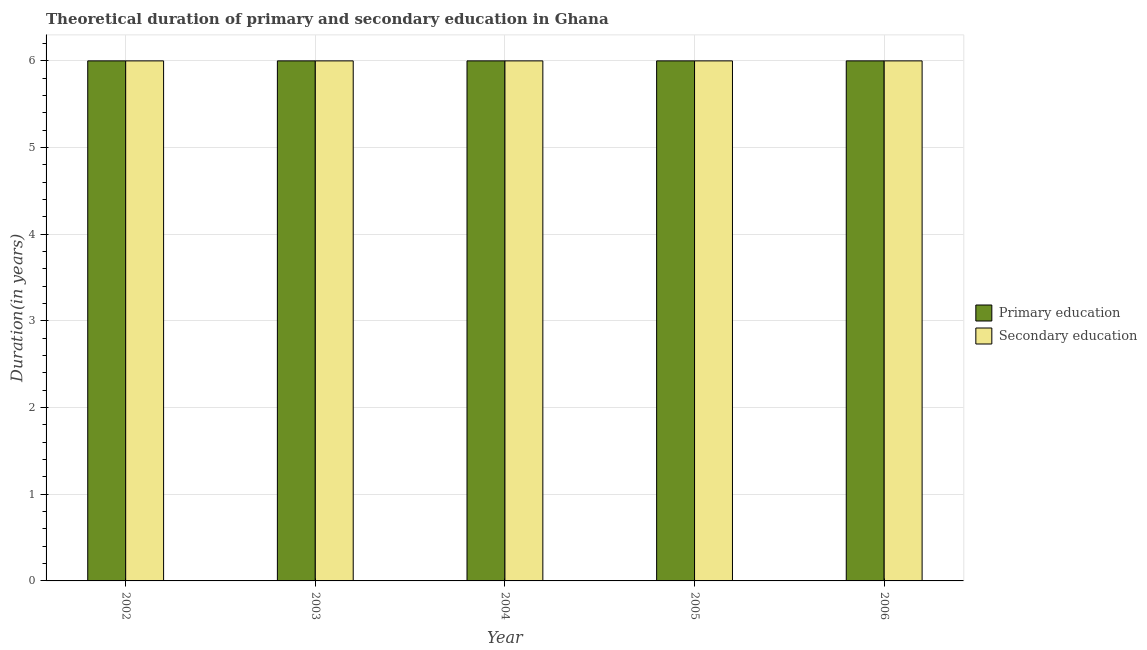How many different coloured bars are there?
Your answer should be compact. 2. Are the number of bars per tick equal to the number of legend labels?
Offer a very short reply. Yes. How many bars are there on the 1st tick from the left?
Ensure brevity in your answer.  2. What is the label of the 1st group of bars from the left?
Your answer should be very brief. 2002. Across all years, what is the maximum duration of primary education?
Make the answer very short. 6. Across all years, what is the minimum duration of secondary education?
Your answer should be compact. 6. What is the total duration of primary education in the graph?
Provide a short and direct response. 30. In the year 2005, what is the difference between the duration of primary education and duration of secondary education?
Keep it short and to the point. 0. In how many years, is the duration of primary education greater than 1.4 years?
Ensure brevity in your answer.  5. Is the duration of primary education in 2003 less than that in 2006?
Your answer should be very brief. No. What is the difference between the highest and the lowest duration of secondary education?
Your answer should be compact. 0. Is the sum of the duration of secondary education in 2003 and 2004 greater than the maximum duration of primary education across all years?
Keep it short and to the point. Yes. What does the 1st bar from the left in 2003 represents?
Offer a very short reply. Primary education. What does the 2nd bar from the right in 2005 represents?
Your answer should be compact. Primary education. How many bars are there?
Offer a terse response. 10. Are all the bars in the graph horizontal?
Provide a short and direct response. No. What is the difference between two consecutive major ticks on the Y-axis?
Keep it short and to the point. 1. Are the values on the major ticks of Y-axis written in scientific E-notation?
Provide a succinct answer. No. Does the graph contain any zero values?
Your answer should be compact. No. Does the graph contain grids?
Offer a very short reply. Yes. Where does the legend appear in the graph?
Make the answer very short. Center right. How many legend labels are there?
Keep it short and to the point. 2. What is the title of the graph?
Offer a very short reply. Theoretical duration of primary and secondary education in Ghana. Does "Ages 15-24" appear as one of the legend labels in the graph?
Offer a terse response. No. What is the label or title of the X-axis?
Make the answer very short. Year. What is the label or title of the Y-axis?
Your answer should be compact. Duration(in years). What is the Duration(in years) in Primary education in 2002?
Ensure brevity in your answer.  6. What is the Duration(in years) of Secondary education in 2002?
Your answer should be very brief. 6. What is the Duration(in years) of Secondary education in 2006?
Keep it short and to the point. 6. Across all years, what is the maximum Duration(in years) in Secondary education?
Your answer should be compact. 6. Across all years, what is the minimum Duration(in years) of Secondary education?
Your answer should be compact. 6. What is the total Duration(in years) of Secondary education in the graph?
Provide a succinct answer. 30. What is the difference between the Duration(in years) of Primary education in 2002 and that in 2003?
Your answer should be very brief. 0. What is the difference between the Duration(in years) of Primary education in 2002 and that in 2004?
Make the answer very short. 0. What is the difference between the Duration(in years) of Secondary education in 2002 and that in 2004?
Your answer should be compact. 0. What is the difference between the Duration(in years) in Secondary education in 2002 and that in 2005?
Offer a terse response. 0. What is the difference between the Duration(in years) of Primary education in 2002 and that in 2006?
Ensure brevity in your answer.  0. What is the difference between the Duration(in years) in Secondary education in 2002 and that in 2006?
Your response must be concise. 0. What is the difference between the Duration(in years) in Primary education in 2003 and that in 2005?
Offer a terse response. 0. What is the difference between the Duration(in years) in Secondary education in 2003 and that in 2006?
Offer a very short reply. 0. What is the difference between the Duration(in years) of Secondary education in 2004 and that in 2005?
Your answer should be very brief. 0. What is the difference between the Duration(in years) in Primary education in 2002 and the Duration(in years) in Secondary education in 2003?
Give a very brief answer. 0. What is the difference between the Duration(in years) in Primary education in 2003 and the Duration(in years) in Secondary education in 2006?
Offer a terse response. 0. What is the difference between the Duration(in years) of Primary education in 2004 and the Duration(in years) of Secondary education in 2005?
Provide a short and direct response. 0. What is the difference between the Duration(in years) in Primary education in 2004 and the Duration(in years) in Secondary education in 2006?
Give a very brief answer. 0. What is the average Duration(in years) in Secondary education per year?
Give a very brief answer. 6. In the year 2002, what is the difference between the Duration(in years) of Primary education and Duration(in years) of Secondary education?
Give a very brief answer. 0. In the year 2004, what is the difference between the Duration(in years) in Primary education and Duration(in years) in Secondary education?
Provide a succinct answer. 0. In the year 2005, what is the difference between the Duration(in years) in Primary education and Duration(in years) in Secondary education?
Make the answer very short. 0. What is the ratio of the Duration(in years) of Primary education in 2002 to that in 2004?
Your response must be concise. 1. What is the ratio of the Duration(in years) in Secondary education in 2002 to that in 2004?
Your answer should be very brief. 1. What is the ratio of the Duration(in years) in Secondary education in 2002 to that in 2005?
Make the answer very short. 1. What is the ratio of the Duration(in years) in Primary education in 2003 to that in 2004?
Your answer should be compact. 1. What is the ratio of the Duration(in years) of Secondary education in 2003 to that in 2004?
Ensure brevity in your answer.  1. What is the ratio of the Duration(in years) of Primary education in 2003 to that in 2005?
Give a very brief answer. 1. What is the ratio of the Duration(in years) in Primary education in 2004 to that in 2005?
Give a very brief answer. 1. What is the ratio of the Duration(in years) of Primary education in 2005 to that in 2006?
Make the answer very short. 1. What is the difference between the highest and the second highest Duration(in years) in Secondary education?
Give a very brief answer. 0. What is the difference between the highest and the lowest Duration(in years) of Secondary education?
Your answer should be very brief. 0. 